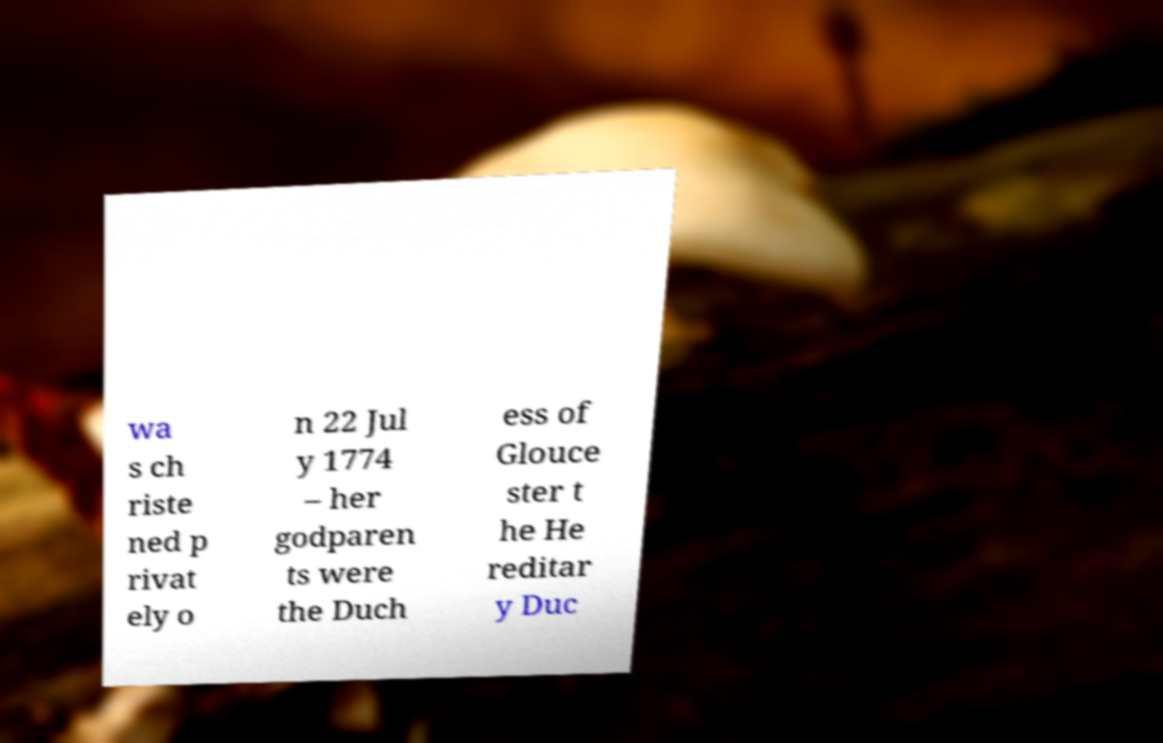For documentation purposes, I need the text within this image transcribed. Could you provide that? wa s ch riste ned p rivat ely o n 22 Jul y 1774 – her godparen ts were the Duch ess of Glouce ster t he He reditar y Duc 